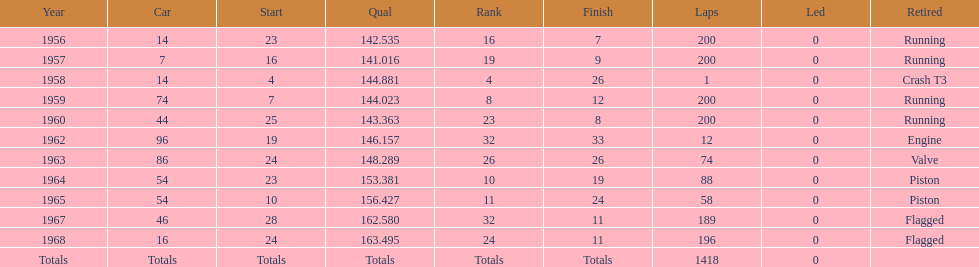How many times did he finish all 200 laps? 4. 